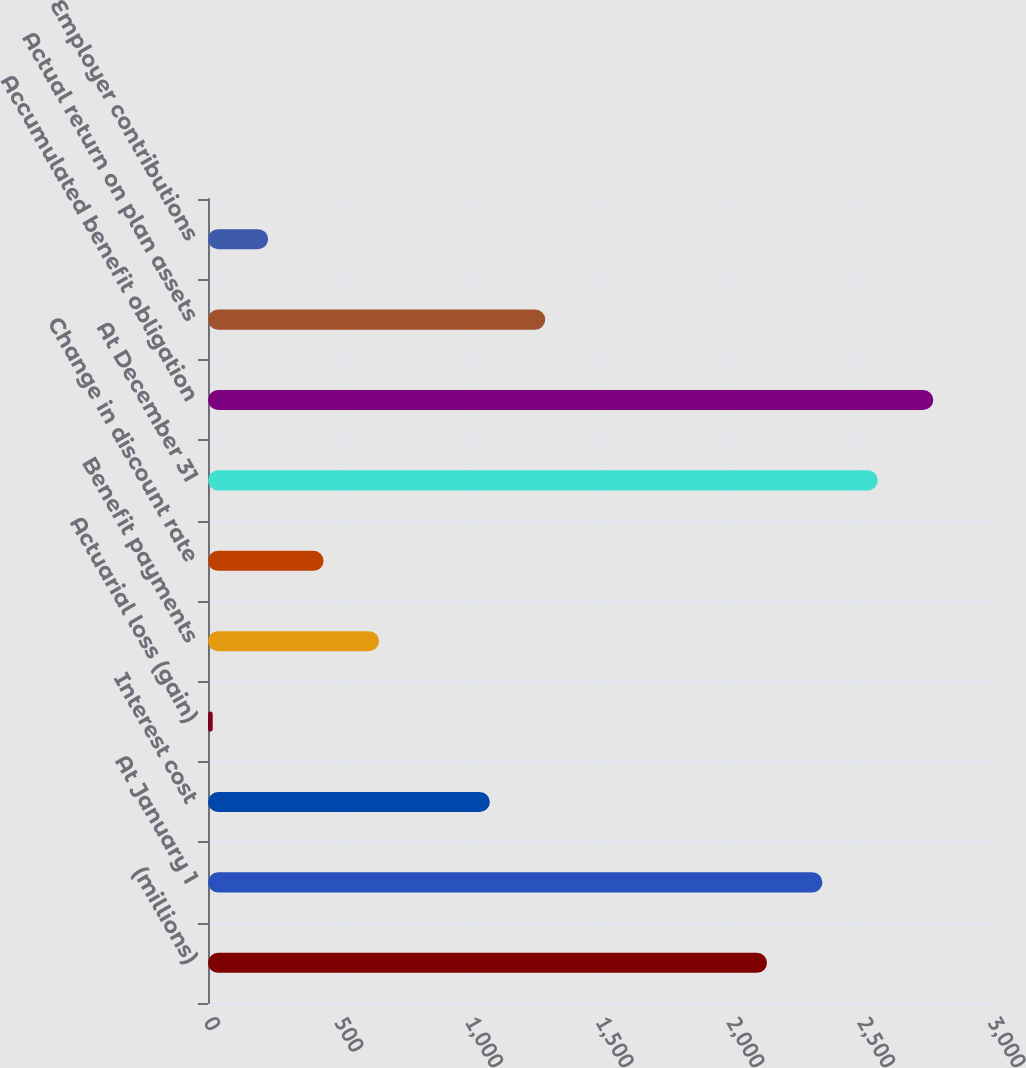<chart> <loc_0><loc_0><loc_500><loc_500><bar_chart><fcel>(millions)<fcel>At January 1<fcel>Interest cost<fcel>Actuarial loss (gain)<fcel>Benefit payments<fcel>Change in discount rate<fcel>At December 31<fcel>Accumulated benefit obligation<fcel>Actual return on plan assets<fcel>Employer contributions<nl><fcel>2139<fcel>2351.1<fcel>1078.5<fcel>18<fcel>654.3<fcel>442.2<fcel>2563.2<fcel>2775.3<fcel>1290.6<fcel>230.1<nl></chart> 